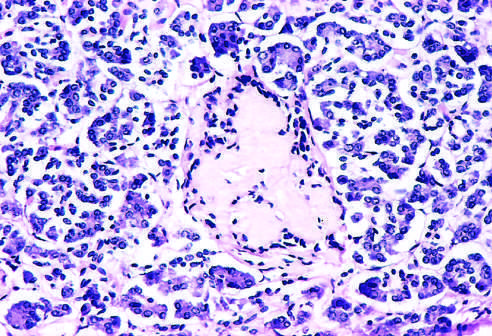what is amyloidosis observed late in?
Answer the question using a single word or phrase. The natural history of this form of diabetes 